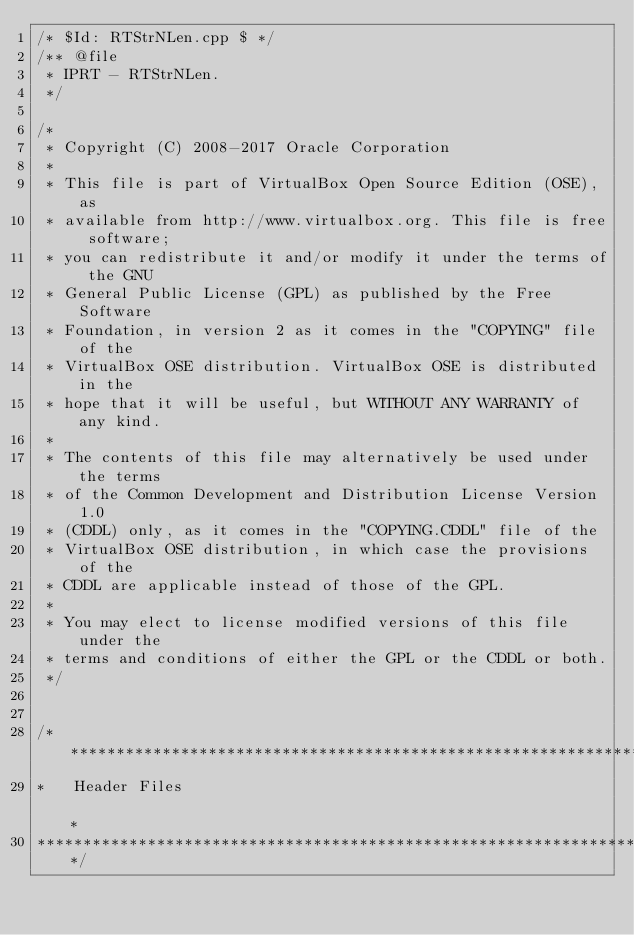Convert code to text. <code><loc_0><loc_0><loc_500><loc_500><_C++_>/* $Id: RTStrNLen.cpp $ */
/** @file
 * IPRT - RTStrNLen.
 */

/*
 * Copyright (C) 2008-2017 Oracle Corporation
 *
 * This file is part of VirtualBox Open Source Edition (OSE), as
 * available from http://www.virtualbox.org. This file is free software;
 * you can redistribute it and/or modify it under the terms of the GNU
 * General Public License (GPL) as published by the Free Software
 * Foundation, in version 2 as it comes in the "COPYING" file of the
 * VirtualBox OSE distribution. VirtualBox OSE is distributed in the
 * hope that it will be useful, but WITHOUT ANY WARRANTY of any kind.
 *
 * The contents of this file may alternatively be used under the terms
 * of the Common Development and Distribution License Version 1.0
 * (CDDL) only, as it comes in the "COPYING.CDDL" file of the
 * VirtualBox OSE distribution, in which case the provisions of the
 * CDDL are applicable instead of those of the GPL.
 *
 * You may elect to license modified versions of this file under the
 * terms and conditions of either the GPL or the CDDL or both.
 */


/*********************************************************************************************************************************
*   Header Files                                                                                                                 *
*********************************************************************************************************************************/</code> 